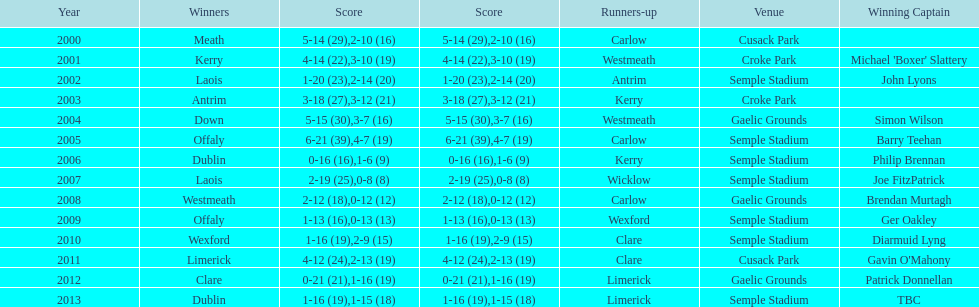Who was the first winning captain? Michael 'Boxer' Slattery. 